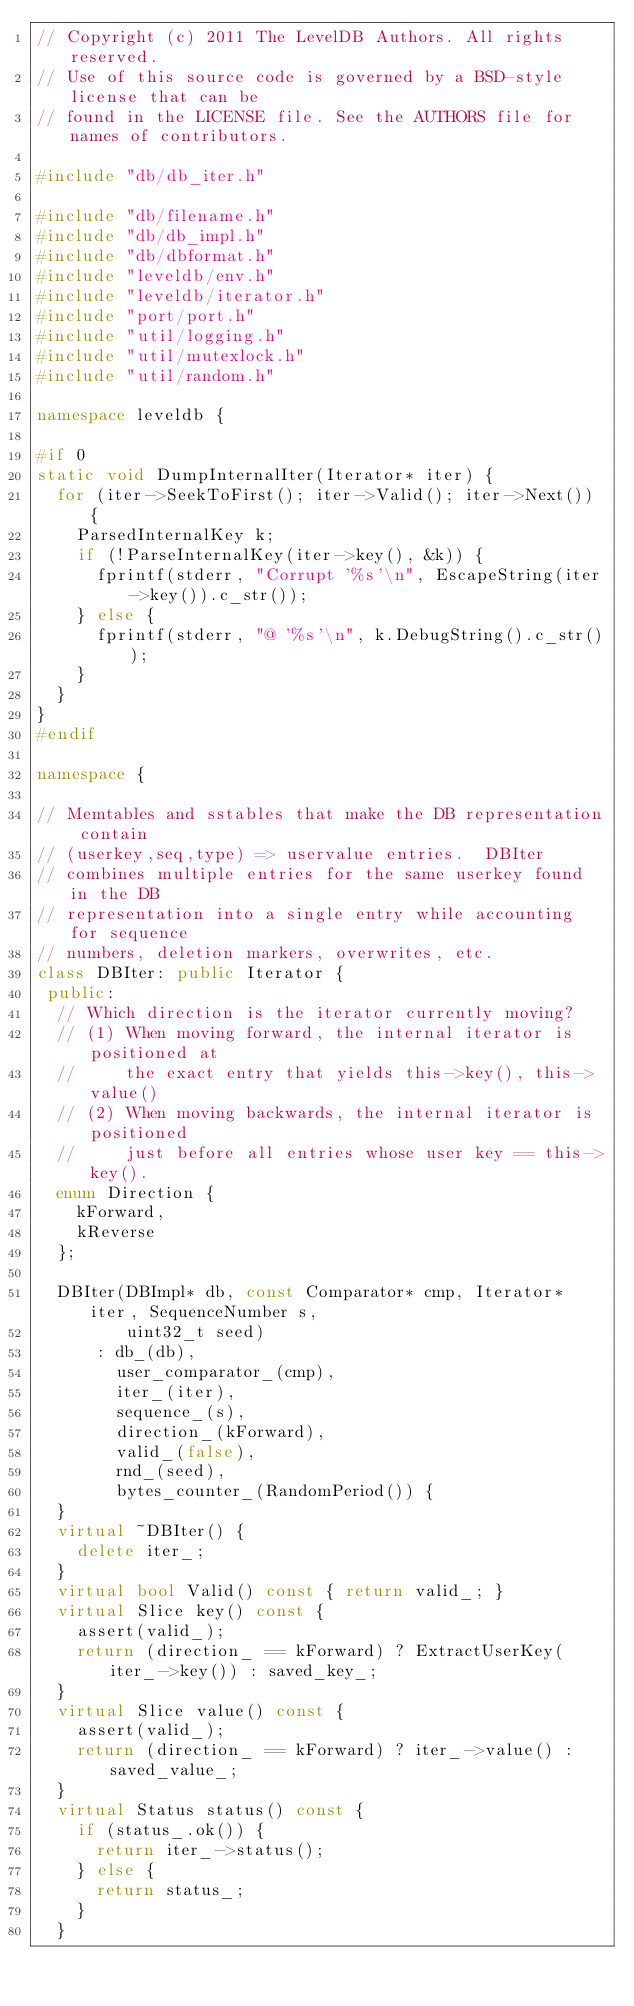Convert code to text. <code><loc_0><loc_0><loc_500><loc_500><_C++_>// Copyright (c) 2011 The LevelDB Authors. All rights reserved.
// Use of this source code is governed by a BSD-style license that can be
// found in the LICENSE file. See the AUTHORS file for names of contributors.

#include "db/db_iter.h"

#include "db/filename.h"
#include "db/db_impl.h"
#include "db/dbformat.h"
#include "leveldb/env.h"
#include "leveldb/iterator.h"
#include "port/port.h"
#include "util/logging.h"
#include "util/mutexlock.h"
#include "util/random.h"

namespace leveldb {

#if 0
static void DumpInternalIter(Iterator* iter) {
  for (iter->SeekToFirst(); iter->Valid(); iter->Next()) {
    ParsedInternalKey k;
    if (!ParseInternalKey(iter->key(), &k)) {
      fprintf(stderr, "Corrupt '%s'\n", EscapeString(iter->key()).c_str());
    } else {
      fprintf(stderr, "@ '%s'\n", k.DebugString().c_str());
    }
  }
}
#endif

namespace {

// Memtables and sstables that make the DB representation contain
// (userkey,seq,type) => uservalue entries.  DBIter
// combines multiple entries for the same userkey found in the DB
// representation into a single entry while accounting for sequence
// numbers, deletion markers, overwrites, etc.
class DBIter: public Iterator {
 public:
  // Which direction is the iterator currently moving?
  // (1) When moving forward, the internal iterator is positioned at
  //     the exact entry that yields this->key(), this->value()
  // (2) When moving backwards, the internal iterator is positioned
  //     just before all entries whose user key == this->key().
  enum Direction {
    kForward,
    kReverse
  };

  DBIter(DBImpl* db, const Comparator* cmp, Iterator* iter, SequenceNumber s,
         uint32_t seed)
      : db_(db),
        user_comparator_(cmp),
        iter_(iter),
        sequence_(s),
        direction_(kForward),
        valid_(false),
        rnd_(seed),
        bytes_counter_(RandomPeriod()) {
  }
  virtual ~DBIter() {
    delete iter_;
  }
  virtual bool Valid() const { return valid_; }
  virtual Slice key() const {
    assert(valid_);
    return (direction_ == kForward) ? ExtractUserKey(iter_->key()) : saved_key_;
  }
  virtual Slice value() const {
    assert(valid_);
    return (direction_ == kForward) ? iter_->value() : saved_value_;
  }
  virtual Status status() const {
    if (status_.ok()) {
      return iter_->status();
    } else {
      return status_;
    }
  }
</code> 